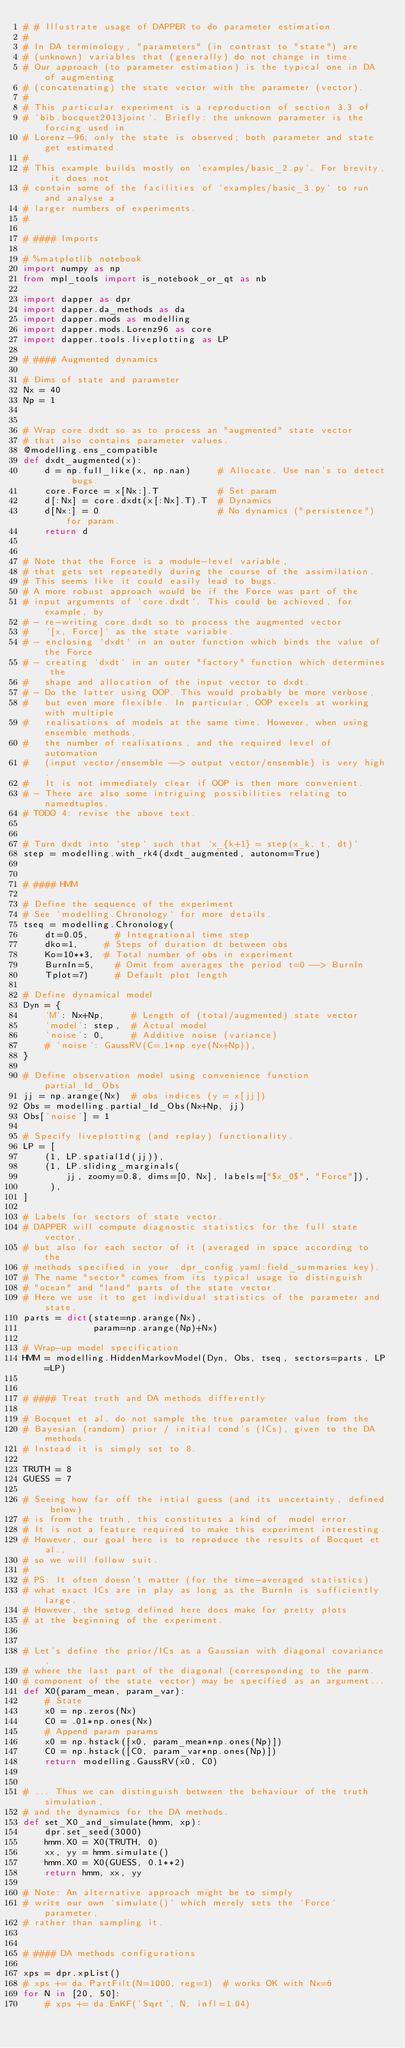<code> <loc_0><loc_0><loc_500><loc_500><_Python_># # Illustrate usage of DAPPER to do parameter estimation.
#
# In DA terminology, "parameters" (in contrast to "state") are
# (unknown) variables that (generally) do not change in time.
# Our approach (to parameter estimation) is the typical one in DA of augmenting
# (concatenating) the state vector with the parameter (vector).
#
# This particular experiment is a reproduction of section 3.3 of
# `bib.bocquet2013joint`. Briefly: the unknown parameter is the forcing used in
# Lorenz-96; only the state is observed; both parameter and state get estimated.
#
# This example builds mostly on `examples/basic_2.py`. For brevity, it does not
# contain some of the facilities of `examples/basic_3.py` to run and analyse a
# larger numbers of experiments.
#

# #### Imports

# %matplotlib notebook
import numpy as np
from mpl_tools import is_notebook_or_qt as nb

import dapper as dpr
import dapper.da_methods as da
import dapper.mods as modelling
import dapper.mods.Lorenz96 as core
import dapper.tools.liveplotting as LP

# #### Augmented dynamics

# Dims of state and parameter
Nx = 40
Np = 1


# Wrap core.dxdt so as to process an "augmented" state vector
# that also contains parameter values.
@modelling.ens_compatible
def dxdt_augmented(x):
    d = np.full_like(x, np.nan)     # Allocate. Use nan's to detect bugs.
    core.Force = x[Nx:].T           # Set param
    d[:Nx] = core.dxdt(x[:Nx].T).T  # Dynamics
    d[Nx:] = 0                      # No dynamics ("persistence") for param.
    return d


# Note that the Force is a module-level variable,
# that gets set repeatedly during the course of the assimilation.
# This seems like it could easily lead to bugs.
# A more robust approach would be if the Force was part of the
# input arguments of `core.dxdt`. This could be achieved, for example, by
# - re-writing core.dxdt so to process the augmented vector
#   `[x, Force]` as the state variable.
# - enclosing `dxdt` in an outer function which binds the value of the Force
# - creating `dxdt` in an outer "factory" function which determines the
#   shape and allocation of the input vector to dxdt.
# - Do the latter using OOP. This would probably be more verbose,
#   but even more flexible. In particular, OOP excels at working with multiple
#   realisations of models at the same time. However, when using ensemble methods,
#   the number of realisations, and the required level of automation
#   (input vector/ensemble --> output vector/ensemble) is very high.
#   It is not immediately clear if OOP is then more convenient.
# - There are also some intriguing possibilities relating to namedtuples.
# TODO 4: revise the above text.


# Turn dxdt into `step` such that `x_{k+1} = step(x_k, t, dt)`
step = modelling.with_rk4(dxdt_augmented, autonom=True)


# #### HMM

# Define the sequence of the experiment
# See `modelling.Chronology` for more details.
tseq = modelling.Chronology(
    dt=0.05,     # Integrational time step
    dko=1,     # Steps of duration dt between obs
    Ko=10**3,  # Total number of obs in experiment
    BurnIn=5,    # Omit from averages the period t=0 --> BurnIn
    Tplot=7)     # Default plot length

# Define dynamical model
Dyn = {
    'M': Nx+Np,     # Length of (total/augmented) state vector
    'model': step,  # Actual model
    'noise': 0,     # Additive noise (variance)
    # 'noise': GaussRV(C=.1*np.eye(Nx+Np)),
}

# Define observation model using convenience function partial_Id_Obs
jj = np.arange(Nx)  # obs indices (y = x[jj])
Obs = modelling.partial_Id_Obs(Nx+Np, jj)
Obs['noise'] = 1

# Specify liveplotting (and replay) functionality.
LP = [
    (1, LP.spatial1d(jj)),
    (1, LP.sliding_marginals(
        jj, zoomy=0.8, dims=[0, Nx], labels=["$x_0$", "Force"]),
     ),
]

# Labels for sectors of state vector.
# DAPPER will compute diagnostic statistics for the full state vector,
# but also for each sector of it (averaged in space according to the
# methods specified in your .dpr_config.yaml:field_summaries key).
# The name "sector" comes from its typical usage to distinguish
# "ocean" and "land" parts of the state vector.
# Here we use it to get individual statistics of the parameter and state.
parts = dict(state=np.arange(Nx),
             param=np.arange(Np)+Nx)

# Wrap-up model specification
HMM = modelling.HiddenMarkovModel(Dyn, Obs, tseq, sectors=parts, LP=LP)


# #### Treat truth and DA methods differently

# Bocquet et al. do not sample the true parameter value from the
# Bayesian (random) prior / initial cond's (ICs), given to the DA methods.
# Instead it is simply set to 8.

TRUTH = 8
GUESS = 7

# Seeing how far off the intial guess (and its uncertainty, defined below)
# is from the truth, this constitutes a kind of  model error.
# It is not a feature required to make this experiment interesting.
# However, our goal here is to reproduce the results of Bocquet et al.,
# so we will follow suit.
#
# PS: It often doesn't matter (for the time-averaged statistics)
# what exact ICs are in play as long as the BurnIn is sufficiently large.
# However, the setup defined here does make for pretty plots
# at the beginning of the experiment.


# Let's define the prior/ICs as a Gaussian with diagonal covariance,
# where the last part of the diagonal (corresponding to the parm.
# component of the state vector) may be specified as an argument...
def X0(param_mean, param_var):
    # State
    x0 = np.zeros(Nx)
    C0 = .01*np.ones(Nx)
    # Append param params
    x0 = np.hstack([x0, param_mean*np.ones(Np)])
    C0 = np.hstack([C0, param_var*np.ones(Np)])
    return modelling.GaussRV(x0, C0)


# ... Thus we can distinguish between the behaviour of the truth simulation,
# and the dynamics for the DA methods.
def set_X0_and_simulate(hmm, xp):
    dpr.set_seed(3000)
    hmm.X0 = X0(TRUTH, 0)
    xx, yy = hmm.simulate()
    hmm.X0 = X0(GUESS, 0.1**2)
    return hmm, xx, yy

# Note: An alternative approach might be to simply
# write our own `simulate()` which merely sets the `Force` parameter,
# rather than sampling it.


# #### DA methods configurations

xps = dpr.xpList()
# xps += da.PartFilt(N=1000, reg=1)  # works OK with Nx=6
for N in [20, 50]:
    # xps += da.EnKF('Sqrt', N, infl=1.04)</code> 